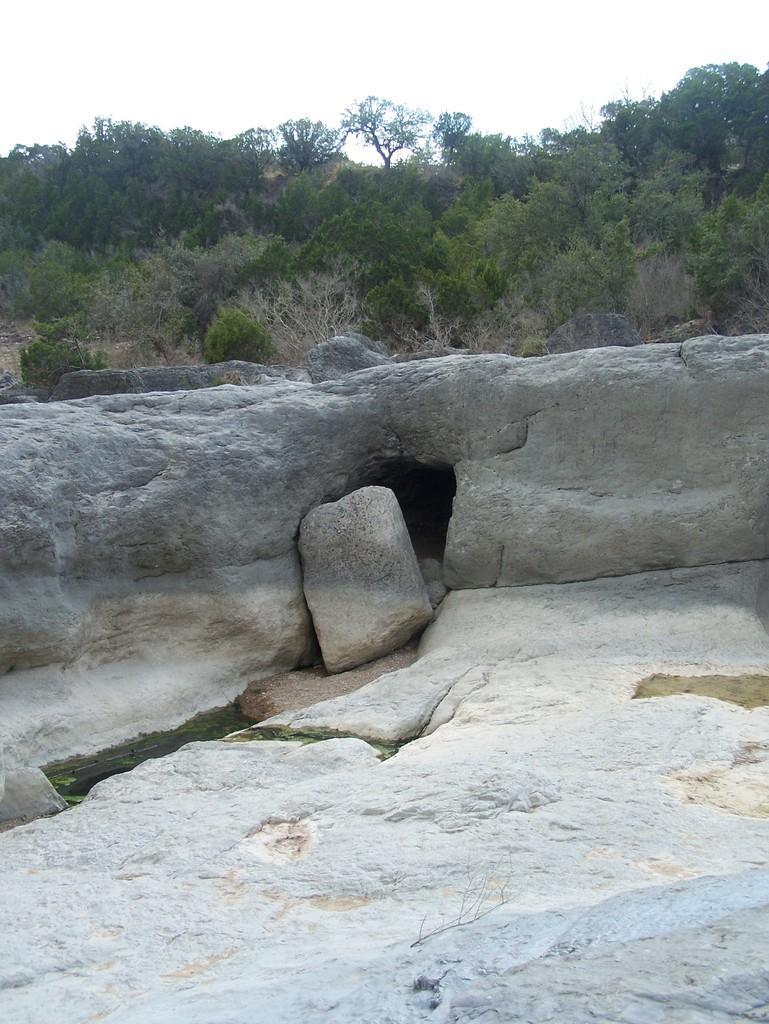Describe this image in one or two sentences. In this image there are rocks. Background there are trees. Top of the image there is sky. Left side there is some water in between the rocks. 